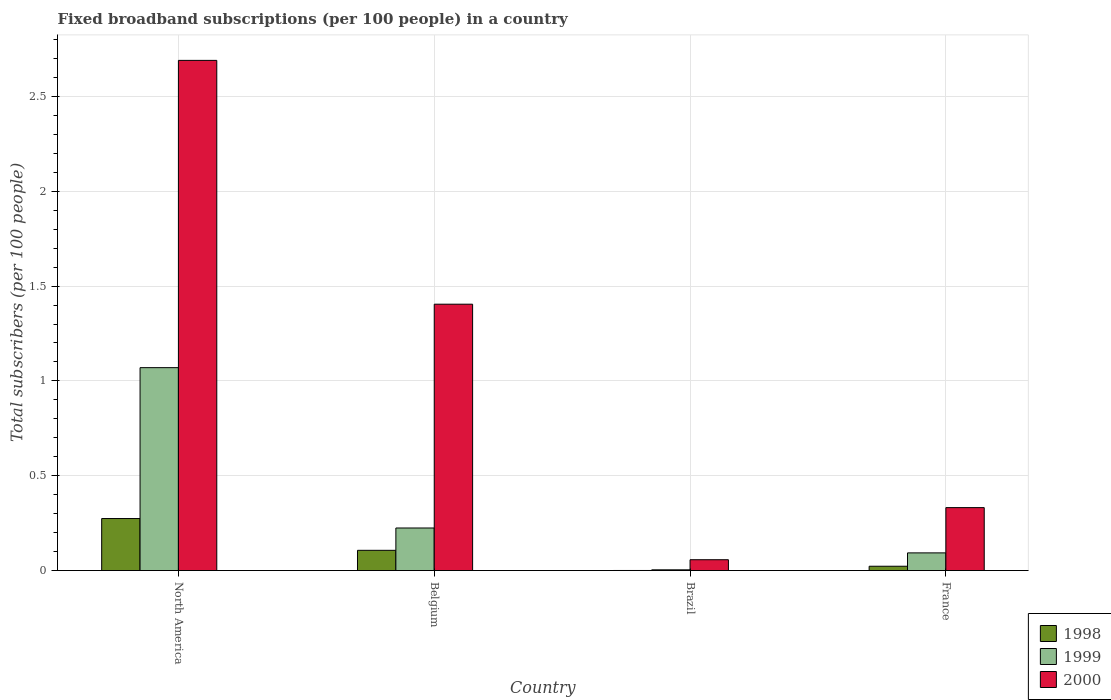How many different coloured bars are there?
Provide a short and direct response. 3. How many groups of bars are there?
Give a very brief answer. 4. Are the number of bars on each tick of the X-axis equal?
Provide a short and direct response. Yes. How many bars are there on the 1st tick from the left?
Ensure brevity in your answer.  3. What is the label of the 4th group of bars from the left?
Offer a very short reply. France. What is the number of broadband subscriptions in 1999 in North America?
Your response must be concise. 1.07. Across all countries, what is the maximum number of broadband subscriptions in 1999?
Offer a terse response. 1.07. Across all countries, what is the minimum number of broadband subscriptions in 2000?
Keep it short and to the point. 0.06. What is the total number of broadband subscriptions in 2000 in the graph?
Keep it short and to the point. 4.48. What is the difference between the number of broadband subscriptions in 1998 in Belgium and that in North America?
Ensure brevity in your answer.  -0.17. What is the difference between the number of broadband subscriptions in 1999 in North America and the number of broadband subscriptions in 1998 in Brazil?
Offer a very short reply. 1.07. What is the average number of broadband subscriptions in 2000 per country?
Your response must be concise. 1.12. What is the difference between the number of broadband subscriptions of/in 2000 and number of broadband subscriptions of/in 1998 in France?
Your answer should be compact. 0.31. In how many countries, is the number of broadband subscriptions in 1999 greater than 0.9?
Offer a very short reply. 1. What is the ratio of the number of broadband subscriptions in 2000 in France to that in North America?
Your response must be concise. 0.12. Is the number of broadband subscriptions in 1999 in Belgium less than that in France?
Give a very brief answer. No. What is the difference between the highest and the second highest number of broadband subscriptions in 2000?
Ensure brevity in your answer.  -1.07. What is the difference between the highest and the lowest number of broadband subscriptions in 2000?
Ensure brevity in your answer.  2.63. In how many countries, is the number of broadband subscriptions in 1998 greater than the average number of broadband subscriptions in 1998 taken over all countries?
Your answer should be very brief. 2. Is the sum of the number of broadband subscriptions in 1998 in Brazil and France greater than the maximum number of broadband subscriptions in 1999 across all countries?
Provide a short and direct response. No. What does the 1st bar from the left in France represents?
Make the answer very short. 1998. Is it the case that in every country, the sum of the number of broadband subscriptions in 1999 and number of broadband subscriptions in 1998 is greater than the number of broadband subscriptions in 2000?
Your answer should be very brief. No. How many bars are there?
Provide a succinct answer. 12. Does the graph contain any zero values?
Make the answer very short. No. Does the graph contain grids?
Offer a very short reply. Yes. Where does the legend appear in the graph?
Make the answer very short. Bottom right. How are the legend labels stacked?
Provide a short and direct response. Vertical. What is the title of the graph?
Your answer should be compact. Fixed broadband subscriptions (per 100 people) in a country. What is the label or title of the Y-axis?
Your answer should be compact. Total subscribers (per 100 people). What is the Total subscribers (per 100 people) in 1998 in North America?
Give a very brief answer. 0.27. What is the Total subscribers (per 100 people) in 1999 in North America?
Ensure brevity in your answer.  1.07. What is the Total subscribers (per 100 people) of 2000 in North America?
Your answer should be compact. 2.69. What is the Total subscribers (per 100 people) of 1998 in Belgium?
Ensure brevity in your answer.  0.11. What is the Total subscribers (per 100 people) in 1999 in Belgium?
Offer a terse response. 0.22. What is the Total subscribers (per 100 people) of 2000 in Belgium?
Make the answer very short. 1.4. What is the Total subscribers (per 100 people) of 1998 in Brazil?
Provide a succinct answer. 0. What is the Total subscribers (per 100 people) of 1999 in Brazil?
Provide a short and direct response. 0. What is the Total subscribers (per 100 people) of 2000 in Brazil?
Give a very brief answer. 0.06. What is the Total subscribers (per 100 people) of 1998 in France?
Give a very brief answer. 0.02. What is the Total subscribers (per 100 people) in 1999 in France?
Your response must be concise. 0.09. What is the Total subscribers (per 100 people) of 2000 in France?
Give a very brief answer. 0.33. Across all countries, what is the maximum Total subscribers (per 100 people) of 1998?
Offer a very short reply. 0.27. Across all countries, what is the maximum Total subscribers (per 100 people) in 1999?
Your answer should be very brief. 1.07. Across all countries, what is the maximum Total subscribers (per 100 people) in 2000?
Keep it short and to the point. 2.69. Across all countries, what is the minimum Total subscribers (per 100 people) of 1998?
Your response must be concise. 0. Across all countries, what is the minimum Total subscribers (per 100 people) in 1999?
Your response must be concise. 0. Across all countries, what is the minimum Total subscribers (per 100 people) in 2000?
Your answer should be very brief. 0.06. What is the total Total subscribers (per 100 people) of 1998 in the graph?
Offer a very short reply. 0.4. What is the total Total subscribers (per 100 people) of 1999 in the graph?
Offer a terse response. 1.39. What is the total Total subscribers (per 100 people) in 2000 in the graph?
Provide a short and direct response. 4.48. What is the difference between the Total subscribers (per 100 people) of 1998 in North America and that in Belgium?
Your response must be concise. 0.17. What is the difference between the Total subscribers (per 100 people) of 1999 in North America and that in Belgium?
Your answer should be very brief. 0.85. What is the difference between the Total subscribers (per 100 people) of 2000 in North America and that in Belgium?
Provide a succinct answer. 1.29. What is the difference between the Total subscribers (per 100 people) in 1998 in North America and that in Brazil?
Provide a succinct answer. 0.27. What is the difference between the Total subscribers (per 100 people) of 1999 in North America and that in Brazil?
Your response must be concise. 1.07. What is the difference between the Total subscribers (per 100 people) in 2000 in North America and that in Brazil?
Your response must be concise. 2.63. What is the difference between the Total subscribers (per 100 people) in 1998 in North America and that in France?
Ensure brevity in your answer.  0.25. What is the difference between the Total subscribers (per 100 people) of 1999 in North America and that in France?
Your answer should be very brief. 0.98. What is the difference between the Total subscribers (per 100 people) of 2000 in North America and that in France?
Your answer should be very brief. 2.36. What is the difference between the Total subscribers (per 100 people) of 1998 in Belgium and that in Brazil?
Your response must be concise. 0.11. What is the difference between the Total subscribers (per 100 people) of 1999 in Belgium and that in Brazil?
Make the answer very short. 0.22. What is the difference between the Total subscribers (per 100 people) of 2000 in Belgium and that in Brazil?
Offer a terse response. 1.35. What is the difference between the Total subscribers (per 100 people) of 1998 in Belgium and that in France?
Make the answer very short. 0.08. What is the difference between the Total subscribers (per 100 people) in 1999 in Belgium and that in France?
Offer a terse response. 0.13. What is the difference between the Total subscribers (per 100 people) in 2000 in Belgium and that in France?
Give a very brief answer. 1.07. What is the difference between the Total subscribers (per 100 people) of 1998 in Brazil and that in France?
Your answer should be very brief. -0.02. What is the difference between the Total subscribers (per 100 people) of 1999 in Brazil and that in France?
Your answer should be compact. -0.09. What is the difference between the Total subscribers (per 100 people) of 2000 in Brazil and that in France?
Your answer should be compact. -0.27. What is the difference between the Total subscribers (per 100 people) of 1998 in North America and the Total subscribers (per 100 people) of 1999 in Belgium?
Give a very brief answer. 0.05. What is the difference between the Total subscribers (per 100 people) of 1998 in North America and the Total subscribers (per 100 people) of 2000 in Belgium?
Your answer should be very brief. -1.13. What is the difference between the Total subscribers (per 100 people) in 1999 in North America and the Total subscribers (per 100 people) in 2000 in Belgium?
Give a very brief answer. -0.33. What is the difference between the Total subscribers (per 100 people) in 1998 in North America and the Total subscribers (per 100 people) in 1999 in Brazil?
Give a very brief answer. 0.27. What is the difference between the Total subscribers (per 100 people) of 1998 in North America and the Total subscribers (per 100 people) of 2000 in Brazil?
Make the answer very short. 0.22. What is the difference between the Total subscribers (per 100 people) in 1999 in North America and the Total subscribers (per 100 people) in 2000 in Brazil?
Make the answer very short. 1.01. What is the difference between the Total subscribers (per 100 people) in 1998 in North America and the Total subscribers (per 100 people) in 1999 in France?
Give a very brief answer. 0.18. What is the difference between the Total subscribers (per 100 people) of 1998 in North America and the Total subscribers (per 100 people) of 2000 in France?
Provide a succinct answer. -0.06. What is the difference between the Total subscribers (per 100 people) of 1999 in North America and the Total subscribers (per 100 people) of 2000 in France?
Keep it short and to the point. 0.74. What is the difference between the Total subscribers (per 100 people) of 1998 in Belgium and the Total subscribers (per 100 people) of 1999 in Brazil?
Ensure brevity in your answer.  0.1. What is the difference between the Total subscribers (per 100 people) of 1998 in Belgium and the Total subscribers (per 100 people) of 2000 in Brazil?
Provide a succinct answer. 0.05. What is the difference between the Total subscribers (per 100 people) of 1999 in Belgium and the Total subscribers (per 100 people) of 2000 in Brazil?
Offer a terse response. 0.17. What is the difference between the Total subscribers (per 100 people) of 1998 in Belgium and the Total subscribers (per 100 people) of 1999 in France?
Your answer should be very brief. 0.01. What is the difference between the Total subscribers (per 100 people) of 1998 in Belgium and the Total subscribers (per 100 people) of 2000 in France?
Make the answer very short. -0.23. What is the difference between the Total subscribers (per 100 people) in 1999 in Belgium and the Total subscribers (per 100 people) in 2000 in France?
Keep it short and to the point. -0.11. What is the difference between the Total subscribers (per 100 people) in 1998 in Brazil and the Total subscribers (per 100 people) in 1999 in France?
Your answer should be very brief. -0.09. What is the difference between the Total subscribers (per 100 people) of 1998 in Brazil and the Total subscribers (per 100 people) of 2000 in France?
Make the answer very short. -0.33. What is the difference between the Total subscribers (per 100 people) in 1999 in Brazil and the Total subscribers (per 100 people) in 2000 in France?
Provide a succinct answer. -0.33. What is the average Total subscribers (per 100 people) in 1998 per country?
Your response must be concise. 0.1. What is the average Total subscribers (per 100 people) of 1999 per country?
Give a very brief answer. 0.35. What is the average Total subscribers (per 100 people) in 2000 per country?
Your answer should be compact. 1.12. What is the difference between the Total subscribers (per 100 people) in 1998 and Total subscribers (per 100 people) in 1999 in North America?
Your answer should be compact. -0.8. What is the difference between the Total subscribers (per 100 people) in 1998 and Total subscribers (per 100 people) in 2000 in North America?
Provide a short and direct response. -2.42. What is the difference between the Total subscribers (per 100 people) in 1999 and Total subscribers (per 100 people) in 2000 in North America?
Offer a terse response. -1.62. What is the difference between the Total subscribers (per 100 people) in 1998 and Total subscribers (per 100 people) in 1999 in Belgium?
Provide a succinct answer. -0.12. What is the difference between the Total subscribers (per 100 people) in 1998 and Total subscribers (per 100 people) in 2000 in Belgium?
Make the answer very short. -1.3. What is the difference between the Total subscribers (per 100 people) of 1999 and Total subscribers (per 100 people) of 2000 in Belgium?
Offer a very short reply. -1.18. What is the difference between the Total subscribers (per 100 people) in 1998 and Total subscribers (per 100 people) in 1999 in Brazil?
Ensure brevity in your answer.  -0. What is the difference between the Total subscribers (per 100 people) in 1998 and Total subscribers (per 100 people) in 2000 in Brazil?
Your response must be concise. -0.06. What is the difference between the Total subscribers (per 100 people) in 1999 and Total subscribers (per 100 people) in 2000 in Brazil?
Make the answer very short. -0.05. What is the difference between the Total subscribers (per 100 people) in 1998 and Total subscribers (per 100 people) in 1999 in France?
Your answer should be compact. -0.07. What is the difference between the Total subscribers (per 100 people) in 1998 and Total subscribers (per 100 people) in 2000 in France?
Offer a very short reply. -0.31. What is the difference between the Total subscribers (per 100 people) of 1999 and Total subscribers (per 100 people) of 2000 in France?
Keep it short and to the point. -0.24. What is the ratio of the Total subscribers (per 100 people) in 1998 in North America to that in Belgium?
Give a very brief answer. 2.57. What is the ratio of the Total subscribers (per 100 people) in 1999 in North America to that in Belgium?
Offer a terse response. 4.76. What is the ratio of the Total subscribers (per 100 people) in 2000 in North America to that in Belgium?
Give a very brief answer. 1.92. What is the ratio of the Total subscribers (per 100 people) in 1998 in North America to that in Brazil?
Give a very brief answer. 465.15. What is the ratio of the Total subscribers (per 100 people) of 1999 in North America to that in Brazil?
Your response must be concise. 262.9. What is the ratio of the Total subscribers (per 100 people) in 2000 in North America to that in Brazil?
Provide a succinct answer. 46.94. What is the ratio of the Total subscribers (per 100 people) of 1998 in North America to that in France?
Provide a short and direct response. 11.95. What is the ratio of the Total subscribers (per 100 people) of 1999 in North America to that in France?
Provide a succinct answer. 11.46. What is the ratio of the Total subscribers (per 100 people) of 2000 in North America to that in France?
Offer a terse response. 8.1. What is the ratio of the Total subscribers (per 100 people) in 1998 in Belgium to that in Brazil?
Provide a short and direct response. 181.1. What is the ratio of the Total subscribers (per 100 people) of 1999 in Belgium to that in Brazil?
Provide a succinct answer. 55.18. What is the ratio of the Total subscribers (per 100 people) of 2000 in Belgium to that in Brazil?
Ensure brevity in your answer.  24.51. What is the ratio of the Total subscribers (per 100 people) of 1998 in Belgium to that in France?
Your answer should be very brief. 4.65. What is the ratio of the Total subscribers (per 100 people) in 1999 in Belgium to that in France?
Make the answer very short. 2.4. What is the ratio of the Total subscribers (per 100 people) of 2000 in Belgium to that in France?
Ensure brevity in your answer.  4.23. What is the ratio of the Total subscribers (per 100 people) in 1998 in Brazil to that in France?
Offer a terse response. 0.03. What is the ratio of the Total subscribers (per 100 people) in 1999 in Brazil to that in France?
Offer a terse response. 0.04. What is the ratio of the Total subscribers (per 100 people) in 2000 in Brazil to that in France?
Your answer should be very brief. 0.17. What is the difference between the highest and the second highest Total subscribers (per 100 people) of 1998?
Your response must be concise. 0.17. What is the difference between the highest and the second highest Total subscribers (per 100 people) in 1999?
Your answer should be very brief. 0.85. What is the difference between the highest and the second highest Total subscribers (per 100 people) in 2000?
Make the answer very short. 1.29. What is the difference between the highest and the lowest Total subscribers (per 100 people) in 1998?
Ensure brevity in your answer.  0.27. What is the difference between the highest and the lowest Total subscribers (per 100 people) of 1999?
Your answer should be very brief. 1.07. What is the difference between the highest and the lowest Total subscribers (per 100 people) of 2000?
Provide a short and direct response. 2.63. 